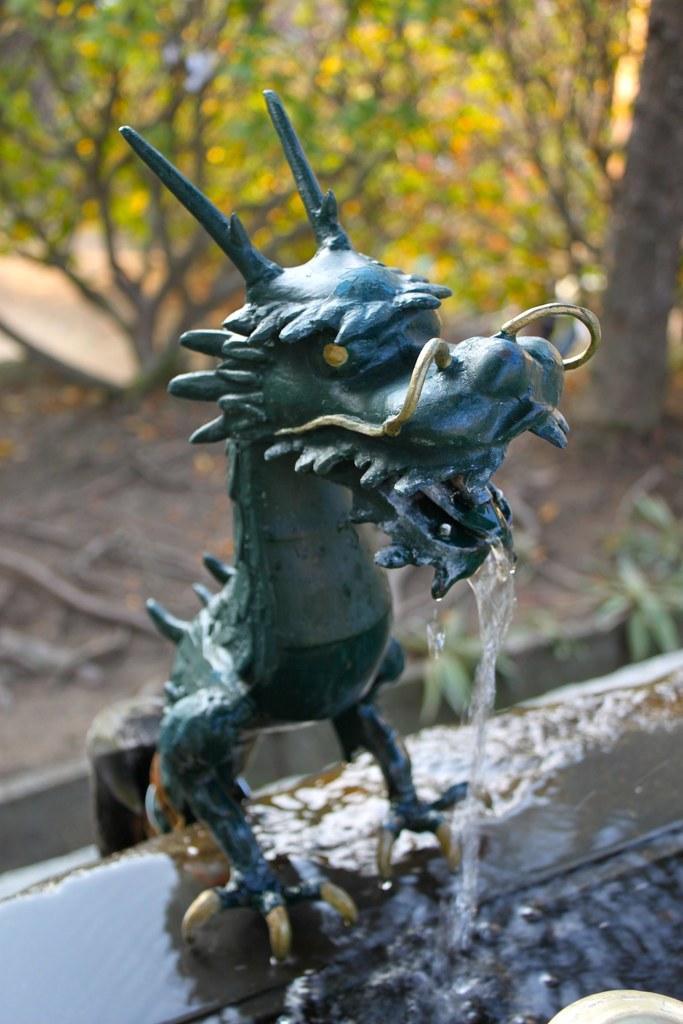Describe this image in one or two sentences. In the image I can see the statue, water and few trees. Background is blurred. 